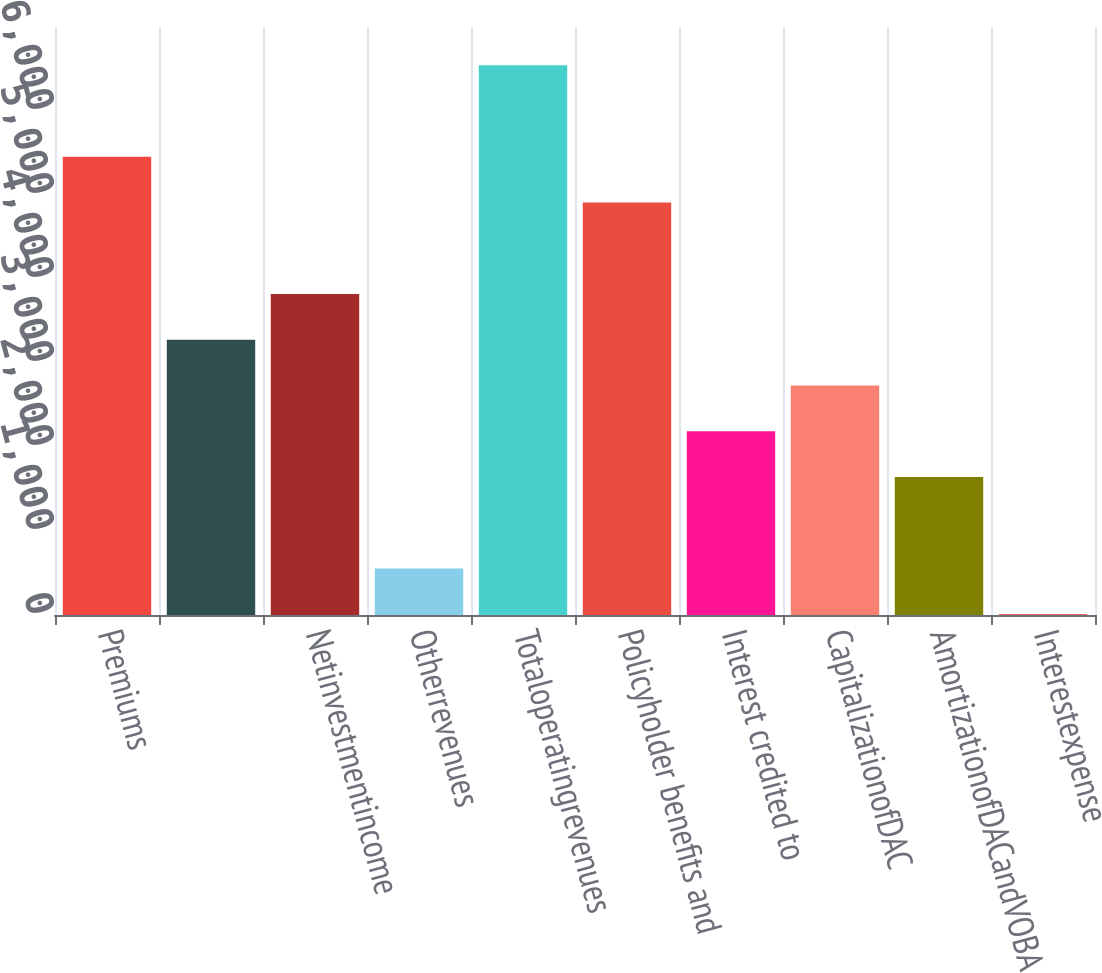Convert chart to OTSL. <chart><loc_0><loc_0><loc_500><loc_500><bar_chart><fcel>Premiums<fcel>Unnamed: 1<fcel>Netinvestmentincome<fcel>Otherrevenues<fcel>Totaloperatingrevenues<fcel>Policyholder benefits and<fcel>Interest credited to<fcel>CapitalizationofDAC<fcel>AmortizationofDACandVOBA<fcel>Interestexpense<nl><fcel>5455<fcel>3276.2<fcel>3820.9<fcel>552.7<fcel>6544.4<fcel>4910.3<fcel>2186.8<fcel>2731.5<fcel>1642.1<fcel>8<nl></chart> 